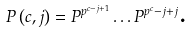Convert formula to latex. <formula><loc_0><loc_0><loc_500><loc_500>P \left ( c , j \right ) = P ^ { p ^ { c - j + 1 } } \dots P ^ { p ^ { c } - j + j } \text {.}</formula> 